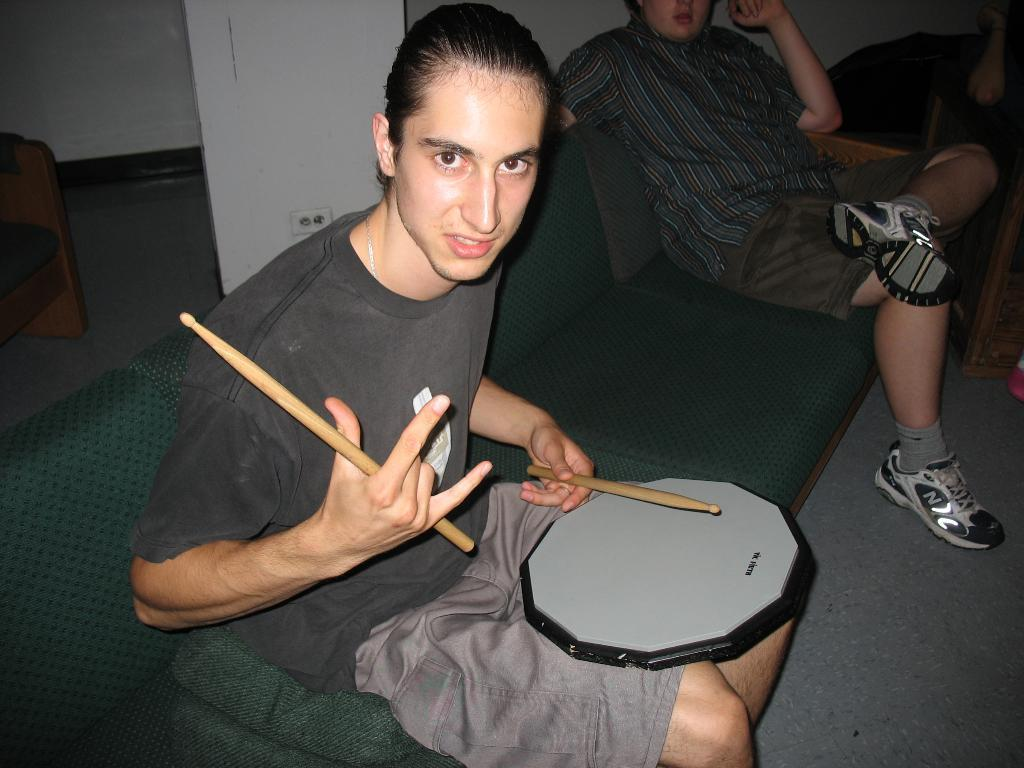What are the people in the image doing? The people in the image are sitting on a sofa. What is the man holding in his hands? The man is holding sticks in his hands. What instrument is the man using? The man has a drum on his lap. What can be seen in the background of the image? There is a pillar and a wall in the background of the image. What type of moon can be seen in the image? There is no moon present in the image. What is the tank used for in the image? There is no tank present in the image. 